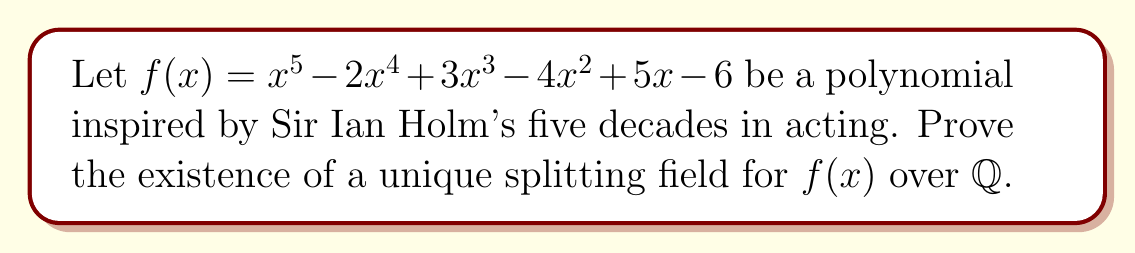What is the answer to this math problem? To prove the existence of a unique splitting field for $f(x)$ over $\mathbb{Q}$, we'll follow these steps:

1) First, recall that a splitting field for a polynomial $f(x)$ over a field $F$ is the smallest field extension of $F$ that contains all the roots of $f(x)$.

2) To show existence, we can construct the splitting field:
   
   a) Let $\alpha_1$ be a root of $f(x)$ in some algebraic closure of $\mathbb{Q}$.
   b) Form $\mathbb{Q}(\alpha_1)$, which is a field extension of $\mathbb{Q}$.
   c) Factor $f(x)$ over $\mathbb{Q}(\alpha_1)$ as $(x-\alpha_1)g(x)$, where $g(x)$ is a polynomial of degree 4.
   d) Let $\alpha_2$ be a root of $g(x)$ in an algebraic closure of $\mathbb{Q}(\alpha_1)$.
   e) Continue this process until all roots $\alpha_1, \alpha_2, \alpha_3, \alpha_4, \alpha_5$ are found.
   f) The field $\mathbb{Q}(\alpha_1, \alpha_2, \alpha_3, \alpha_4, \alpha_5)$ is a splitting field for $f(x)$ over $\mathbb{Q}$.

3) To prove uniqueness, we use the following theorem:
   If $K$ and $L$ are splitting fields of a polynomial $f(x)$ over a field $F$, then there exists an isomorphism $\phi: K \rightarrow L$ such that $\phi|_F = id_F$.

4) The proof of this theorem relies on the fact that any two roots of an irreducible polynomial over a field are conjugate, and hence there exists an isomorphism mapping one to the other.

5) Since $f(x)$ is of degree 5, its splitting field is of degree dividing 5! = 120 over $\mathbb{Q}$. The Galois group of the splitting field is a subgroup of $S_5$.

6) The uniqueness of the splitting field follows from the fact that any two isomorphic field extensions of $\mathbb{Q}$ can be identified, making the splitting field unique up to isomorphism.
Answer: The splitting field exists and is unique up to isomorphism. 